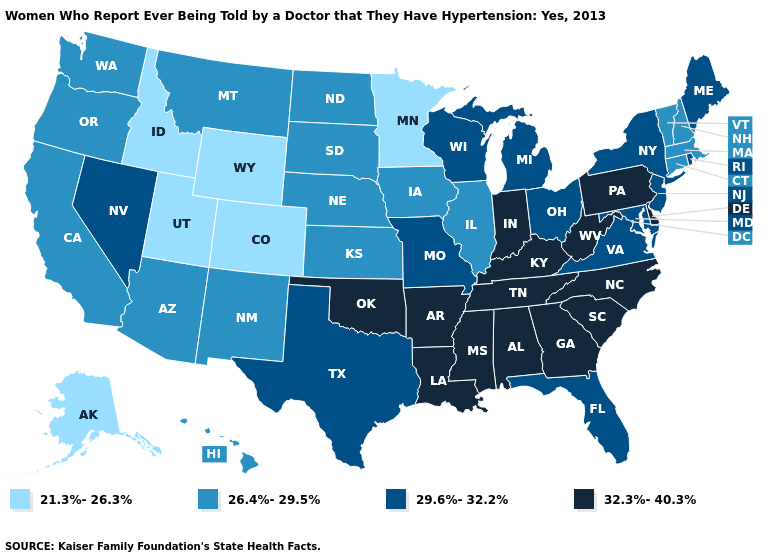Does Maryland have the lowest value in the South?
Quick response, please. Yes. Does Pennsylvania have a higher value than Tennessee?
Concise answer only. No. Which states have the lowest value in the USA?
Keep it brief. Alaska, Colorado, Idaho, Minnesota, Utah, Wyoming. Which states hav the highest value in the West?
Concise answer only. Nevada. Among the states that border Kansas , which have the highest value?
Quick response, please. Oklahoma. Name the states that have a value in the range 26.4%-29.5%?
Quick response, please. Arizona, California, Connecticut, Hawaii, Illinois, Iowa, Kansas, Massachusetts, Montana, Nebraska, New Hampshire, New Mexico, North Dakota, Oregon, South Dakota, Vermont, Washington. What is the lowest value in the USA?
Write a very short answer. 21.3%-26.3%. Among the states that border Texas , does New Mexico have the highest value?
Give a very brief answer. No. What is the value of Kentucky?
Be succinct. 32.3%-40.3%. Does the first symbol in the legend represent the smallest category?
Keep it brief. Yes. What is the highest value in the MidWest ?
Quick response, please. 32.3%-40.3%. What is the value of South Carolina?
Short answer required. 32.3%-40.3%. Name the states that have a value in the range 21.3%-26.3%?
Concise answer only. Alaska, Colorado, Idaho, Minnesota, Utah, Wyoming. What is the highest value in the South ?
Short answer required. 32.3%-40.3%. Does Pennsylvania have the lowest value in the Northeast?
Write a very short answer. No. 